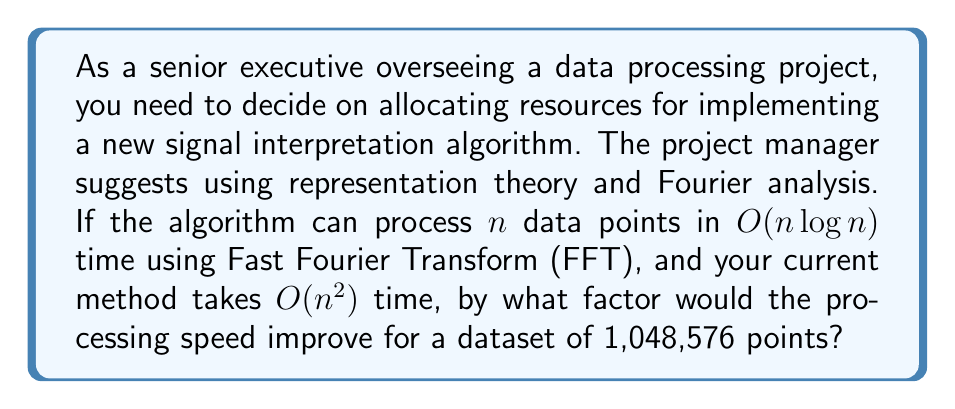Provide a solution to this math problem. Let's approach this step-by-step:

1) The current method takes $O(n^2)$ time, while the proposed method using FFT takes $O(n \log n)$ time.

2) We need to compare these for $n = 1,048,576 = 2^{20}$.

3) For the current method:
   $T_1 = k_1 n^2 = k_1 (1,048,576)^2 = k_1 \cdot 2^{40}$

4) For the proposed FFT method:
   $T_2 = k_2 n \log n = k_2 \cdot 1,048,576 \cdot \log_2(1,048,576) = k_2 \cdot 2^{20} \cdot 20$

5) The speed improvement factor is:
   $$\frac{T_1}{T_2} = \frac{k_1 \cdot 2^{40}}{k_2 \cdot 2^{20} \cdot 20} = \frac{k_1}{k_2} \cdot \frac{2^{20}}{20}$$

6) Assuming $k_1 \approx k_2$ (which is reasonable for comparing asymptotic complexities):
   $$\frac{T_1}{T_2} \approx \frac{2^{20}}{20} = \frac{1,048,576}{20} = 52,428.8$$

Therefore, the processing speed would improve by a factor of approximately 52,429.
Answer: 52,429 